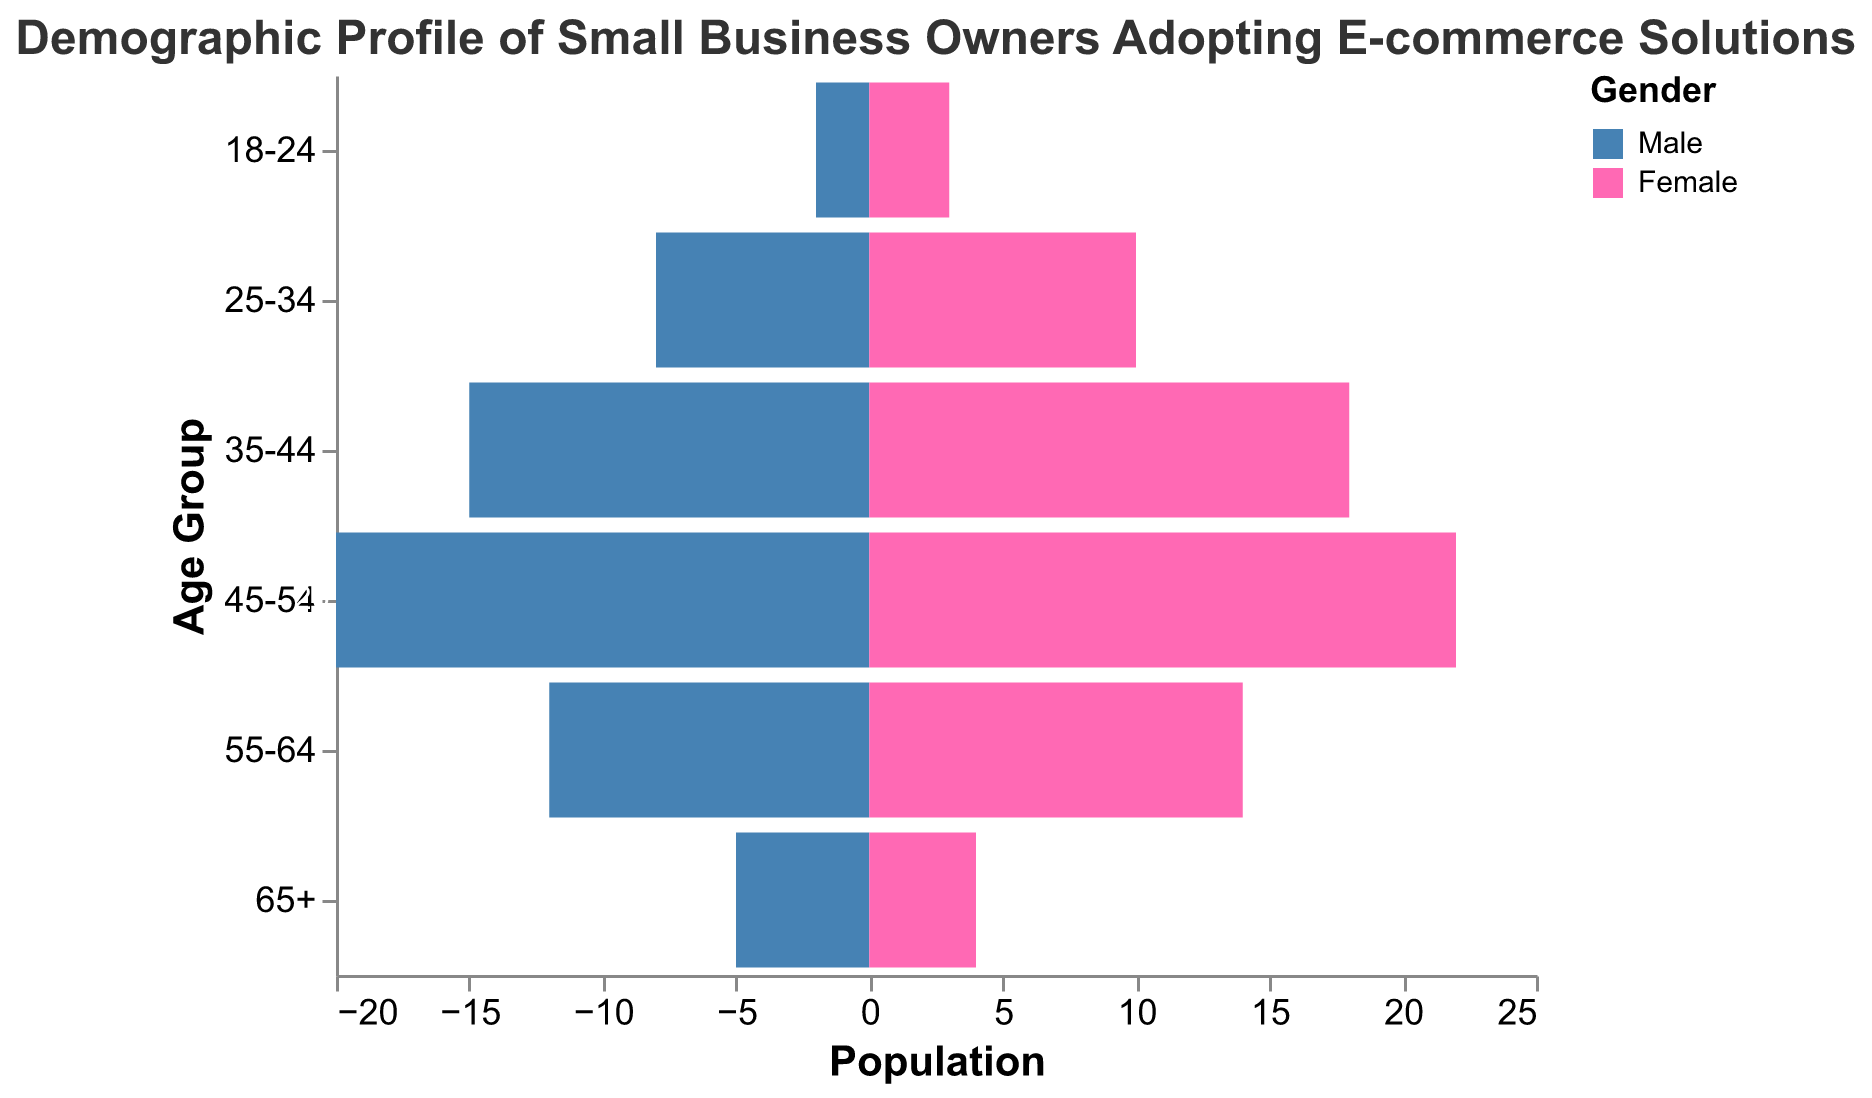What is the title of the figure? The title is displayed at the top of the figure. It reads, "Demographic Profile of Small Business Owners Adopting E-commerce Solutions".
Answer: Demographic Profile of Small Business Owners Adopting E-commerce Solutions How many age groups are represented in the figure? The y-axis of the figure shows the age groups. There are six distinct age groups listed.
Answer: Six What color represents female small business owners? The legend of the figure uses different colors to represent genders. The color for "Female" is pink.
Answer: Pink Which age group has the highest number of male small business owners? By comparing the lengths of the bars on the left for each age group, the 45-54 age group has the longest bar, representing 20 males.
Answer: 45-54 What is the sum of male small business owners in the age groups 35-44 and 45-54? Add the values for males in the two mentioned age groups. 15 (35-44) + 20 (45-54) = 35.
Answer: 35 How does the number of female small business owners in the 25-34 age group compare to the number of male small business owners in the same group? The figure shows 10 females and 8 males in the 25-34 age group. Females are 2 more than males in that group.
Answer: More For the 65+ age group, who has a larger representation, males or females? By comparing the lengths of the bars for 65+, there are 5 males and 4 females. Males have a slightly larger representation.
Answer: Males What is the total population of small business owners aged 55-64? Summing up the values for both genders in the 55-64 age group, 12 males + 14 females = 26.
Answer: 26 What is the average number of female small business owners across all age groups? Sum the values for females across all age groups and divide by the number of age groups: (3 + 10 + 18 + 22 + 14 + 4) / 6 = 11.83.
Answer: 11.83 Which age group has the closest male-to-female ratio? By comparing the number of males and females in each age group, the 65+ age group has 5 males and 4 females, the closest ratio.
Answer: 65+ 